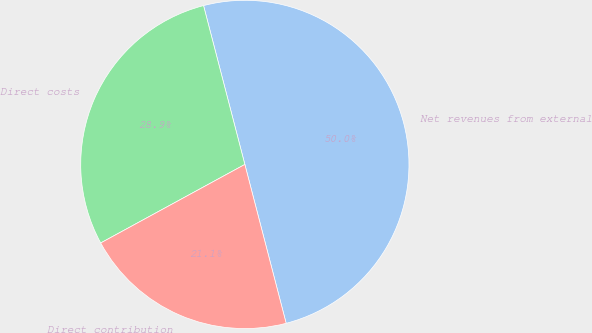<chart> <loc_0><loc_0><loc_500><loc_500><pie_chart><fcel>Net revenues from external<fcel>Direct costs<fcel>Direct contribution<nl><fcel>50.0%<fcel>28.89%<fcel>21.11%<nl></chart> 